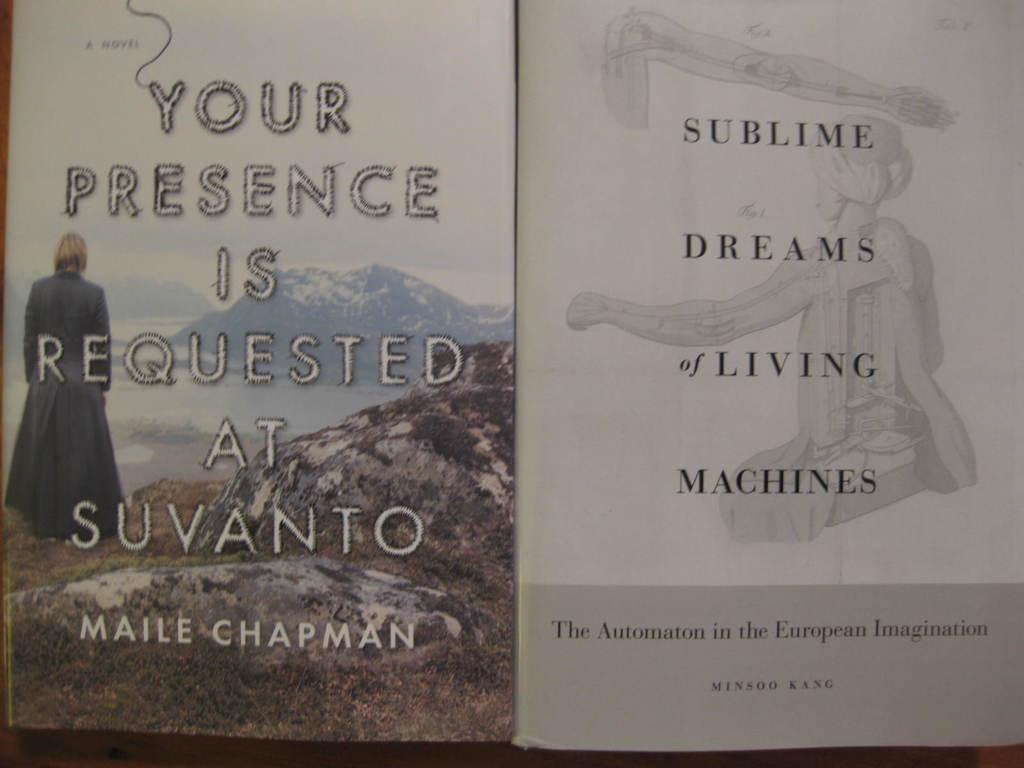Who is the author of the book shown?
Provide a short and direct response. Maile chapman. What is the name of this book?
Give a very brief answer. Your presence is requested at suvanto. 